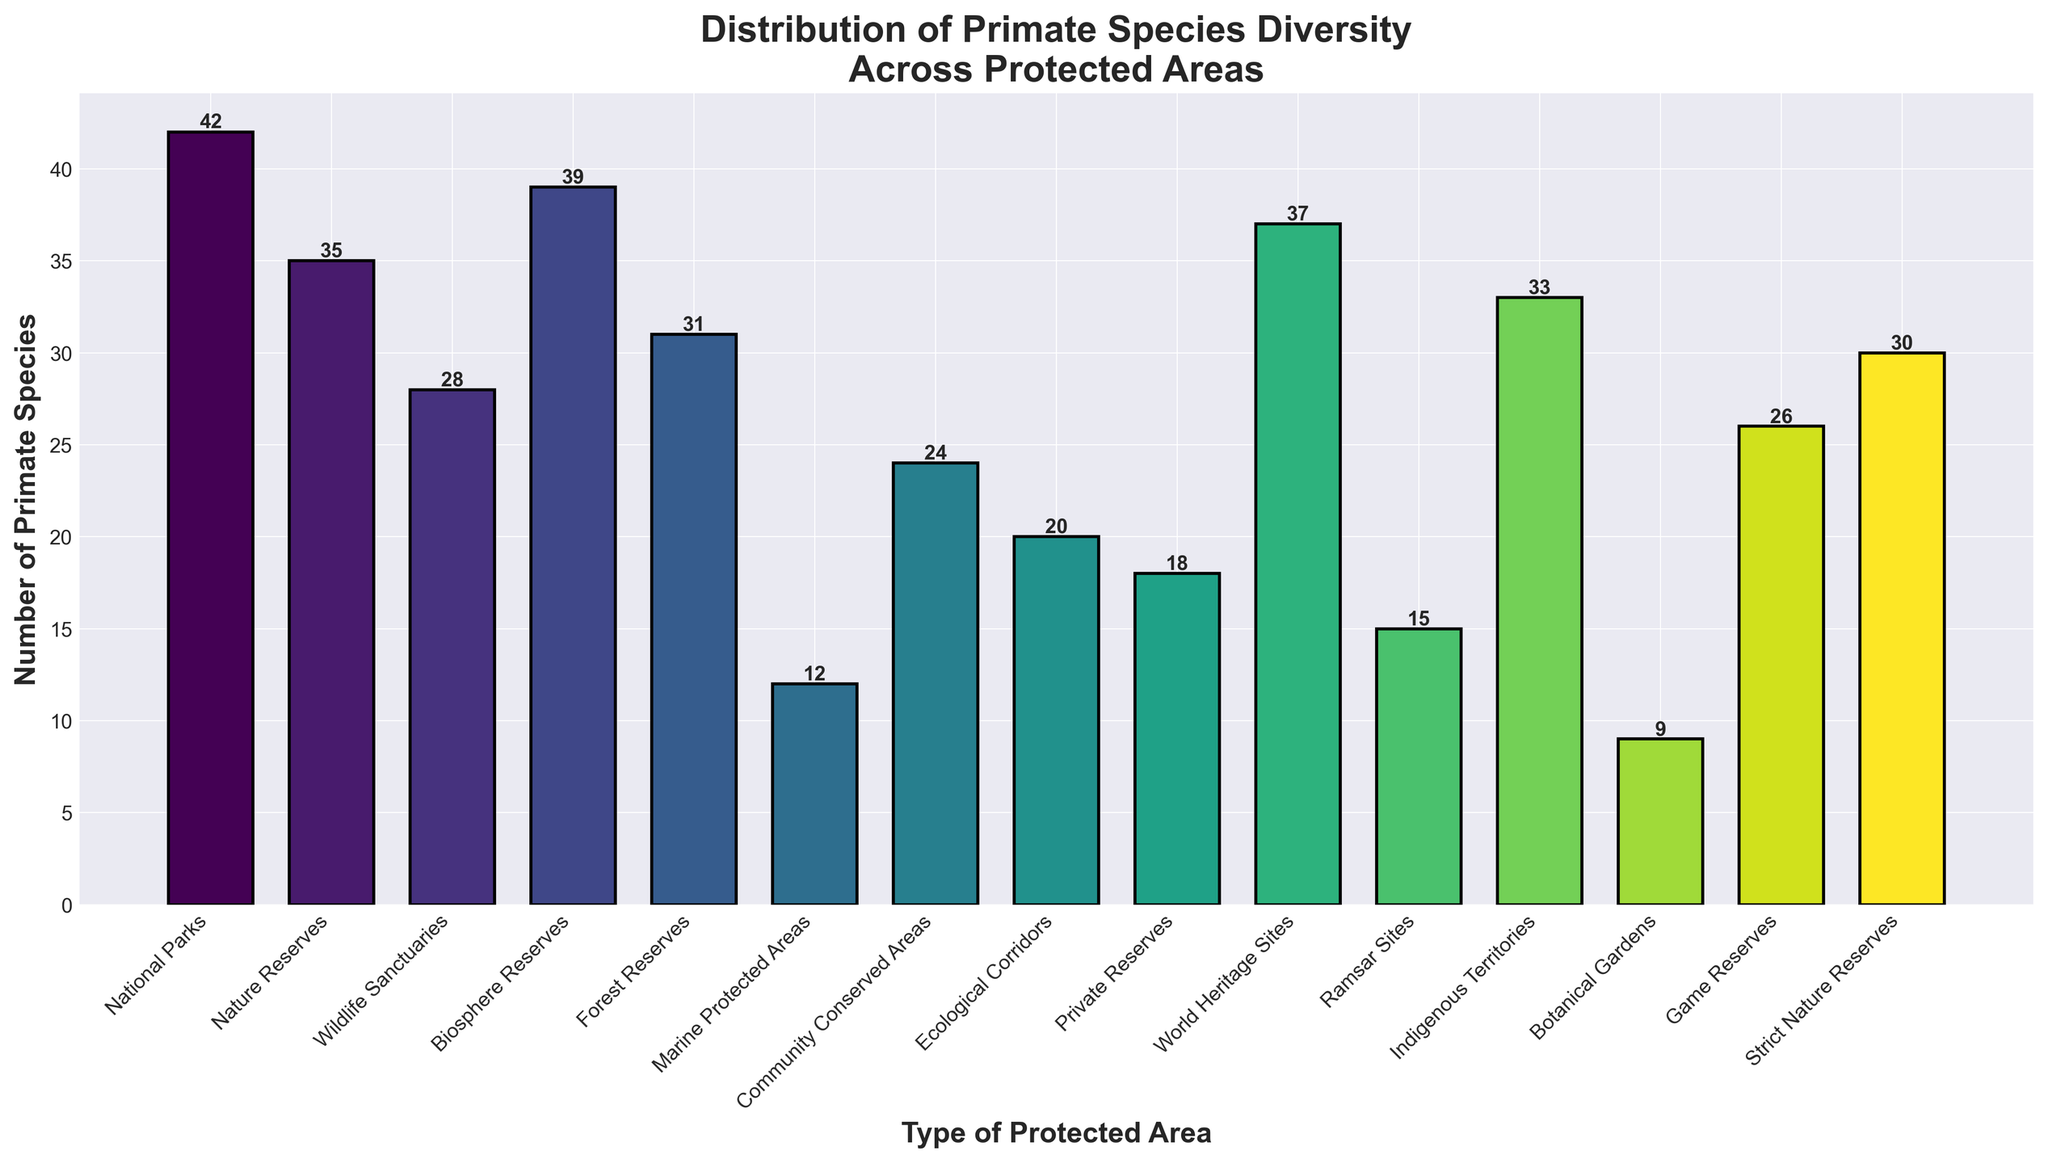Which type of protected area has the highest number of primate species? Look at the specific bar with the greatest height. National Parks have the highest bar.
Answer: National Parks How many more primate species are found in National Parks compared to Botanical Gardens? Subtract the number of species in Botanical Gardens from the number of species in National Parks (42 - 9).
Answer: 33 Which type of protected area has the lowest number of primate species? Identify the bar with the shortest height. Botanical Gardens have the shortest bar.
Answer: Botanical Gardens Is the number of primate species in World Heritage Sites greater than in Forest Reserves? Find the heights corresponding to World Heritage Sites and Forest Reserves and compare them (37 > 31).
Answer: Yes What is the average number of primate species across all protected areas? Sum all the numbers and divide by the total number of protected areas: (42 + 35 + 28 + 39 + 31 + 12 + 24 + 20 + 18 + 37 + 15 + 33 + 9 + 26 + 30) / 15 = 26.2
Answer: 26.2 What is the difference in the number of species between Marine Protected Areas and Community Conserved Areas? Subtract the number of species in Marine Protected Areas from those in Community Conserved Areas (24 - 12).
Answer: 12 Which types of protected areas have more than 30 primate species? Identify the bars with heights greater than 30: National Parks, Biosphere Reserves, World Heritage Sites, Indigenous Territories, Nature Reserves, Forest Reserves, Strict Nature Reserves.
Answer: National Parks, Biosphere Reserves, World Heritage Sites, Indigenous Territories, Nature Reserves, Forest Reserves, Strict Nature Reserves Which two types of protected areas have the closest number of primate species diversity? Identify the pairs of bars with similar heights. Game Reserves (26) and Community Conserved Areas (24) are closest.
Answer: Game Reserves and Community Conserved Areas Is the number of primate species in Nature Reserves greater than the sum of species in Marine Protected Areas and Botanical Gardens? Compare the total of Marine Protected Areas and Botanical Gardens to Nature Reserves (12 + 9) < (35).
Answer: Yes How many types of protected areas have fewer than 20 primate species? Count the bars with heights less than 20: Marine Protected Areas, Botanical Gardens, Private Reserves, Ramsar Sites, Ecological Corridors.
Answer: 5 